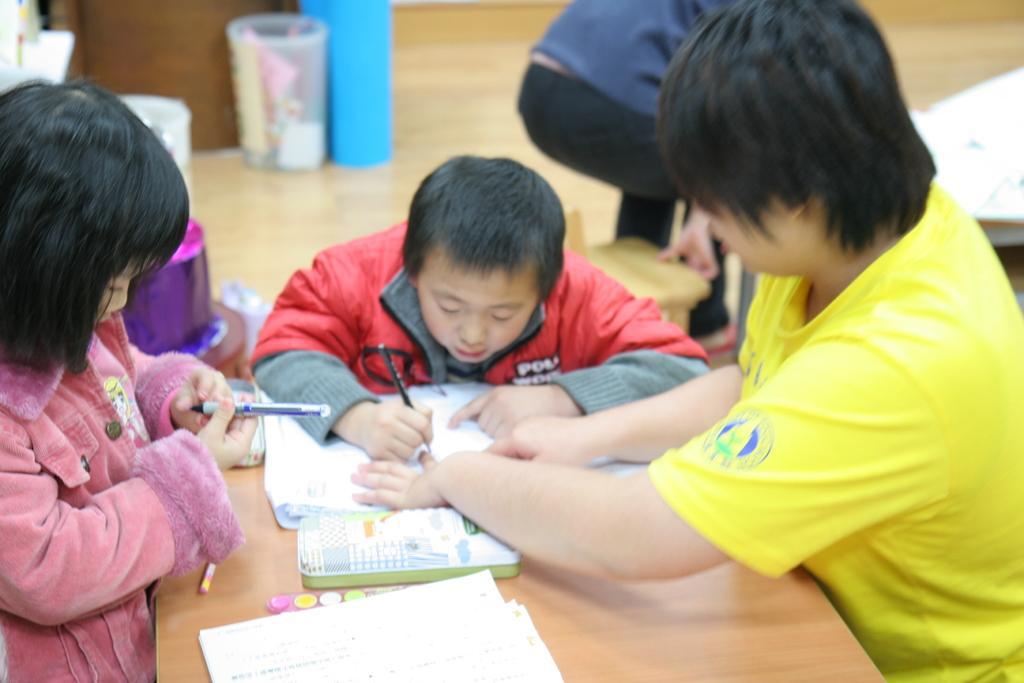Please provide a concise description of this image. In the image we can see there are people around and wearing clothes. Here we can see a wooden sheet, on it there are papers and other objects kept. There is a dustbin and a wooden floor. 